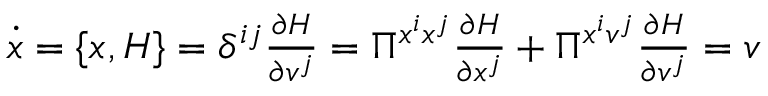<formula> <loc_0><loc_0><loc_500><loc_500>\begin{array} { r } { \dot { x } = \{ x , H \} = \delta ^ { i j } \frac { \partial H } { \partial v ^ { j } } = \Pi ^ { x ^ { i } x ^ { j } } \frac { \partial H } { \partial x ^ { j } } + \Pi ^ { x ^ { i } v ^ { j } } \frac { \partial H } { \partial v ^ { j } } = v } \end{array}</formula> 